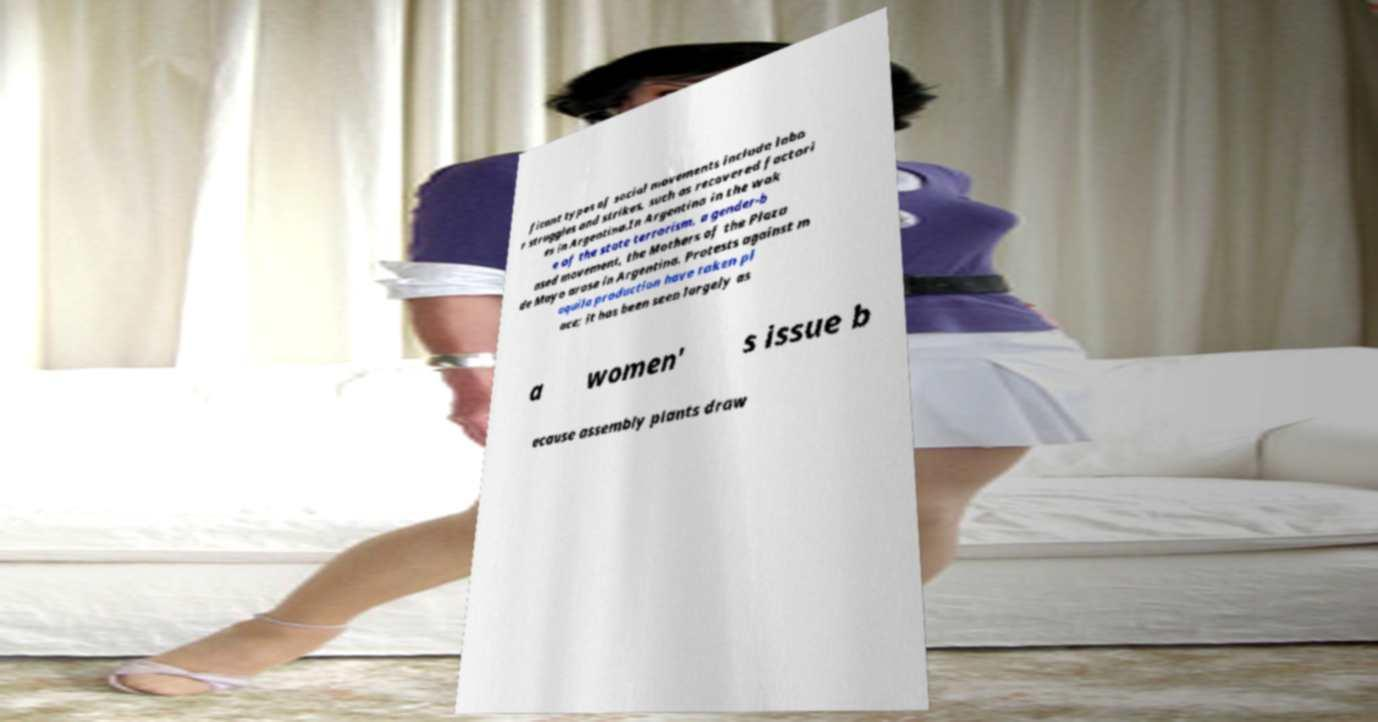For documentation purposes, I need the text within this image transcribed. Could you provide that? ficant types of social movements include labo r struggles and strikes, such as recovered factori es in Argentina.In Argentina in the wak e of the state terrorism, a gender-b ased movement, the Mothers of the Plaza de Mayo arose in Argentina. Protests against m aquila production have taken pl ace; it has been seen largely as a women' s issue b ecause assembly plants draw 